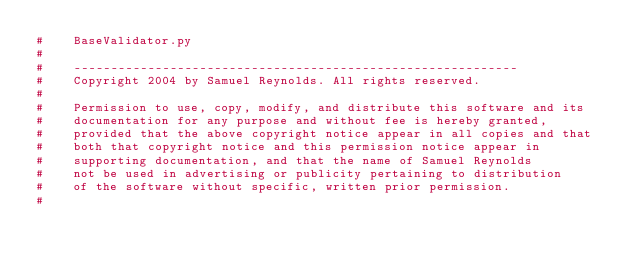Convert code to text. <code><loc_0><loc_0><loc_500><loc_500><_Python_>#    BaseValidator.py
#
#    ------------------------------------------------------------
#    Copyright 2004 by Samuel Reynolds. All rights reserved.
#
#    Permission to use, copy, modify, and distribute this software and its
#    documentation for any purpose and without fee is hereby granted,
#    provided that the above copyright notice appear in all copies and that
#    both that copyright notice and this permission notice appear in
#    supporting documentation, and that the name of Samuel Reynolds
#    not be used in advertising or publicity pertaining to distribution
#    of the software without specific, written prior permission.
#</code> 